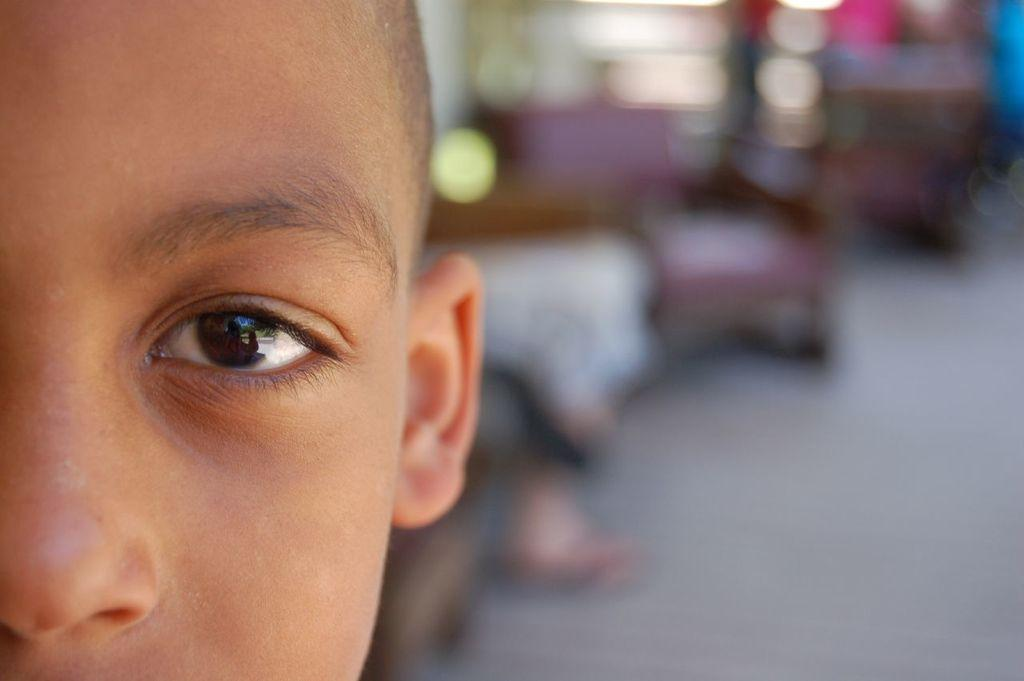What is the main subject of the image? There is a kid's face in the image. Can you describe the background of the image? The background of the image is blurred. What committee is responsible for the title of the kid in the image? There is no committee or title mentioned in the image, as it only features a kid's face with a blurred background. 